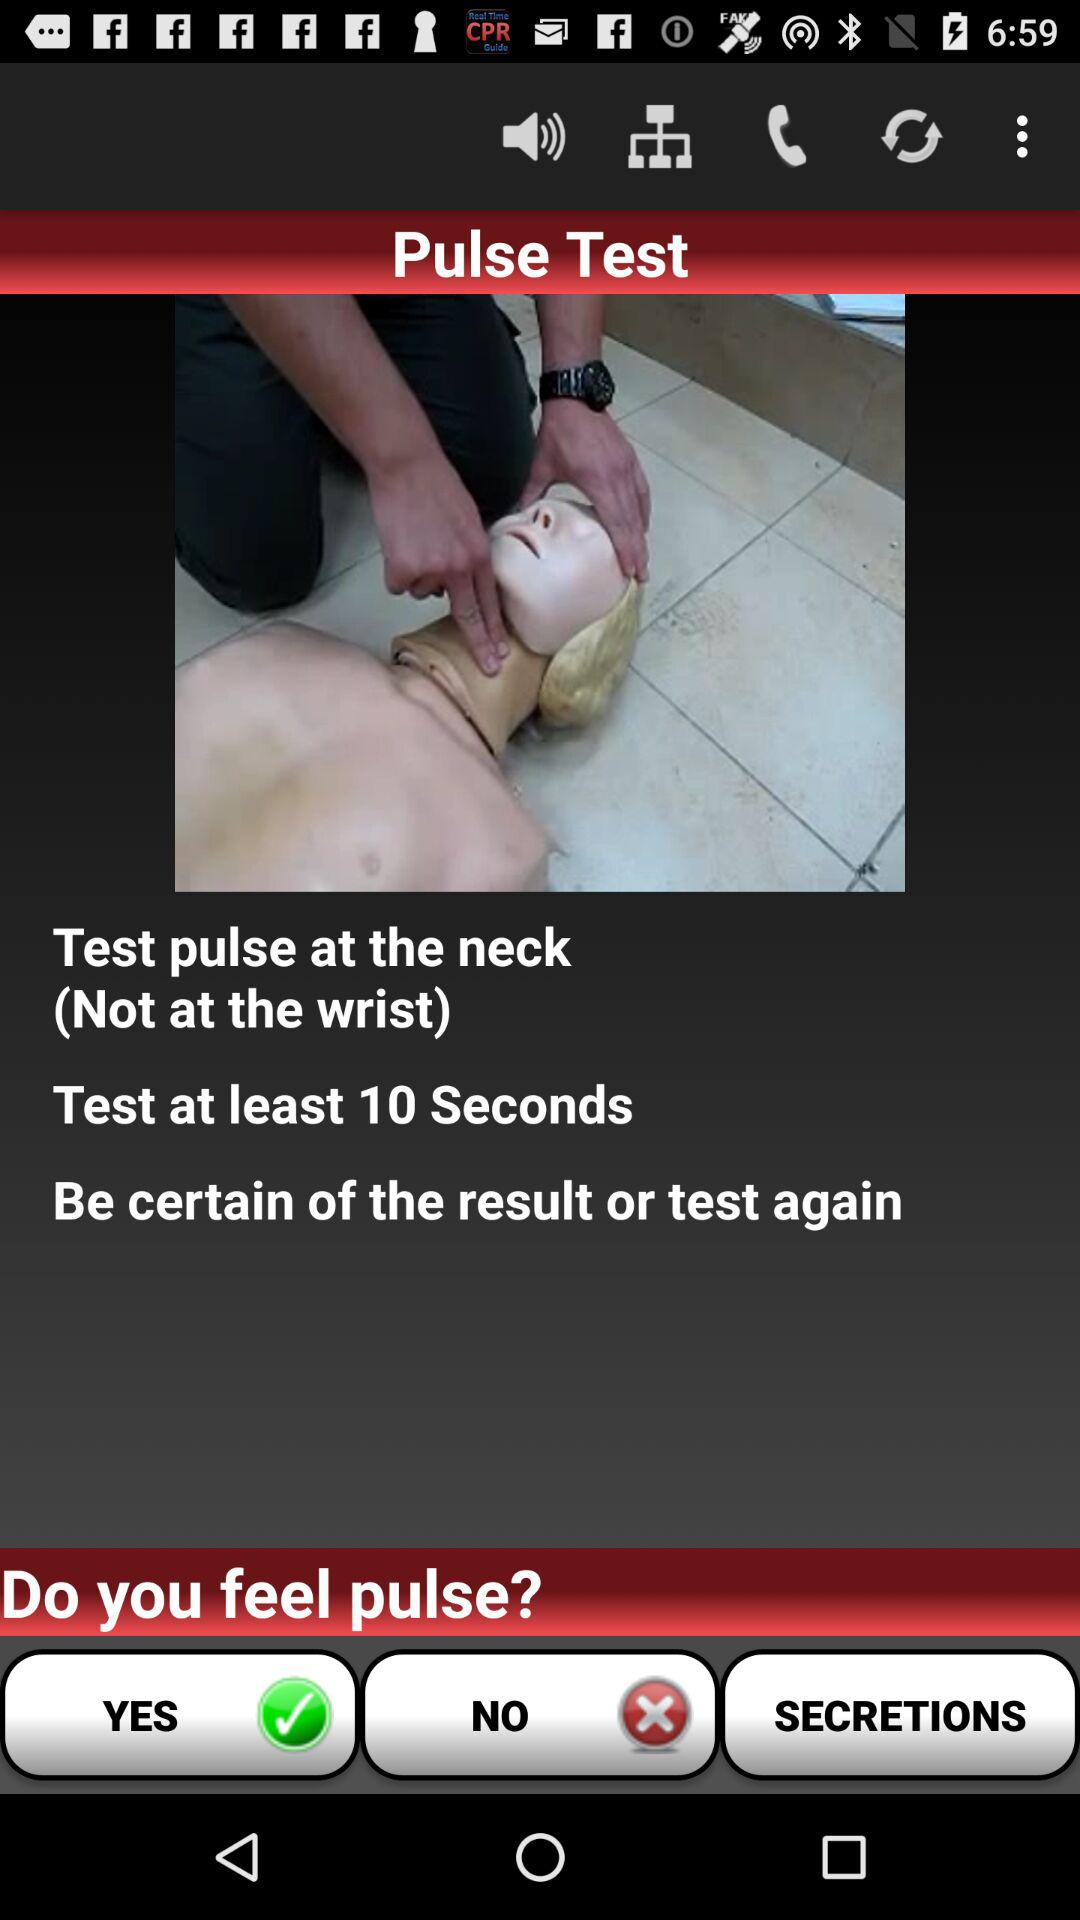Which body part is recommended to test pulse? The recommended body part is the neck. 